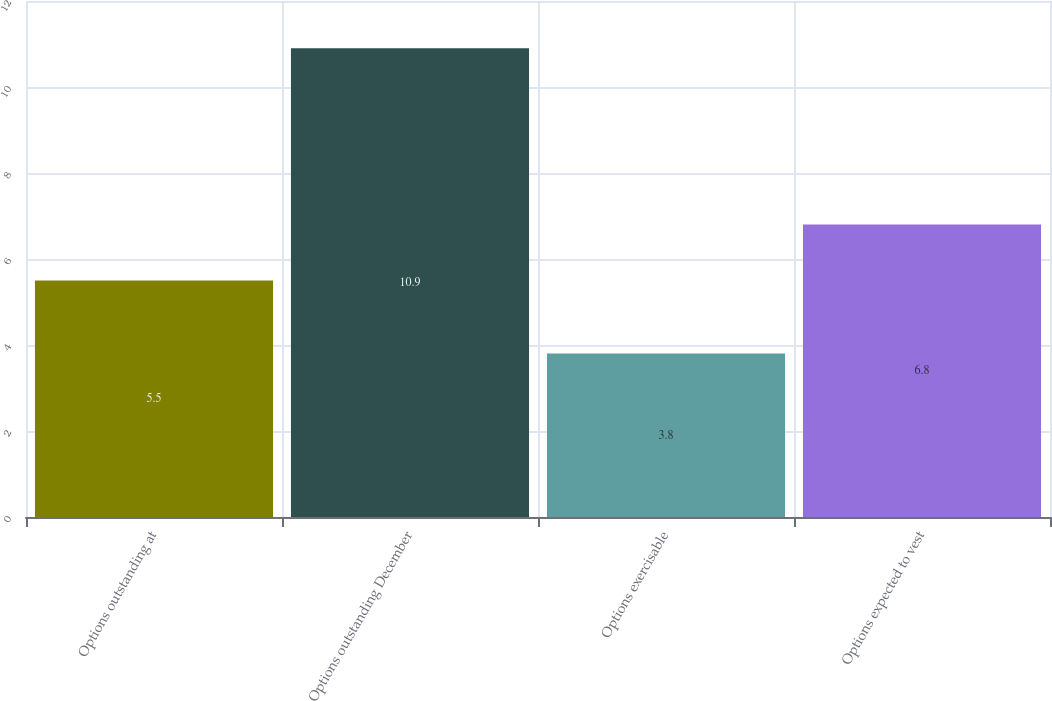<chart> <loc_0><loc_0><loc_500><loc_500><bar_chart><fcel>Options outstanding at<fcel>Options outstanding December<fcel>Options exercisable<fcel>Options expected to vest<nl><fcel>5.5<fcel>10.9<fcel>3.8<fcel>6.8<nl></chart> 